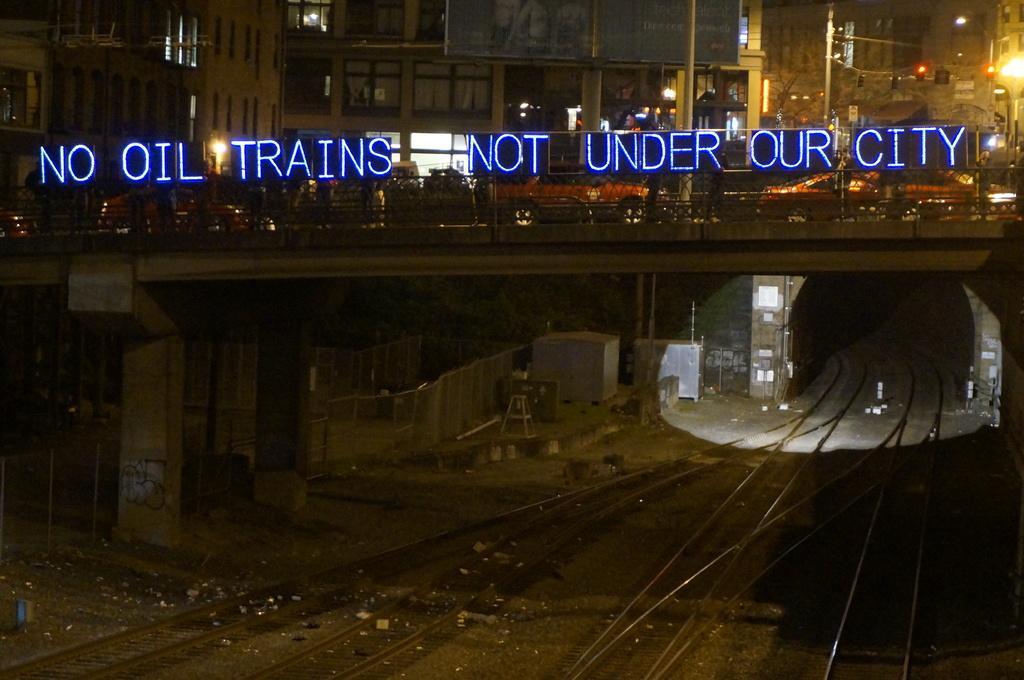Can you describe this image briefly? In the foreground of the picture I can see the railway tracks. I can see the bridge and there are vehicles on the bridge. In the background, I can see the buildings. I can see the lights on the top right side. I can see an LED name board. I can see the pillar and the metal grill fence on the side of the railway track on the left side. 